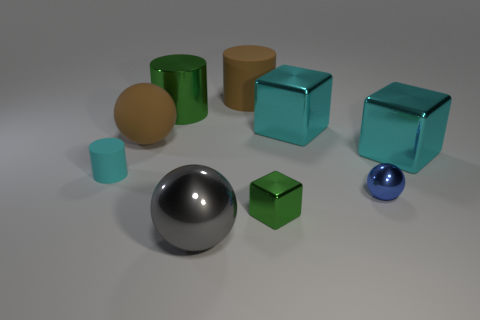Add 1 big red rubber spheres. How many objects exist? 10 Subtract all spheres. How many objects are left? 6 Add 7 small green shiny cubes. How many small green shiny cubes are left? 8 Add 5 big balls. How many big balls exist? 7 Subtract 1 brown balls. How many objects are left? 8 Subtract all cyan shiny objects. Subtract all large cyan blocks. How many objects are left? 5 